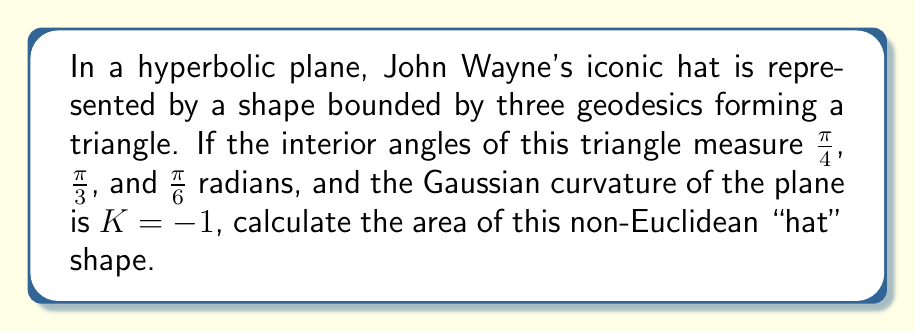Can you answer this question? To solve this problem, we'll use the Gauss-Bonnet formula for hyperbolic geometry:

1) The Gauss-Bonnet formula for a hyperbolic triangle states:
   $$A = \pi - (\alpha + \beta + \gamma)$$
   where $A$ is the area and $\alpha$, $\beta$, and $\gamma$ are the interior angles.

2) We're given the interior angles:
   $\alpha = \frac{\pi}{4}$, $\beta = \frac{\pi}{3}$, and $\gamma = \frac{\pi}{6}$

3) Substituting these into the formula:
   $$A = \pi - (\frac{\pi}{4} + \frac{\pi}{3} + \frac{\pi}{6})$$

4) Simplify the right side:
   $$A = \pi - (\frac{3\pi}{12} + \frac{4\pi}{12} + \frac{2\pi}{12})$$
   $$A = \pi - \frac{9\pi}{12}$$

5) Subtract:
   $$A = \frac{12\pi}{12} - \frac{9\pi}{12} = \frac{3\pi}{12} = \frac{\pi}{4}$$

6) Since the Gaussian curvature $K = -1$, the area is directly given by this value.

Therefore, the area of John Wayne's hyperbolic hat is $\frac{\pi}{4}$ square units.
Answer: $\frac{\pi}{4}$ square units 